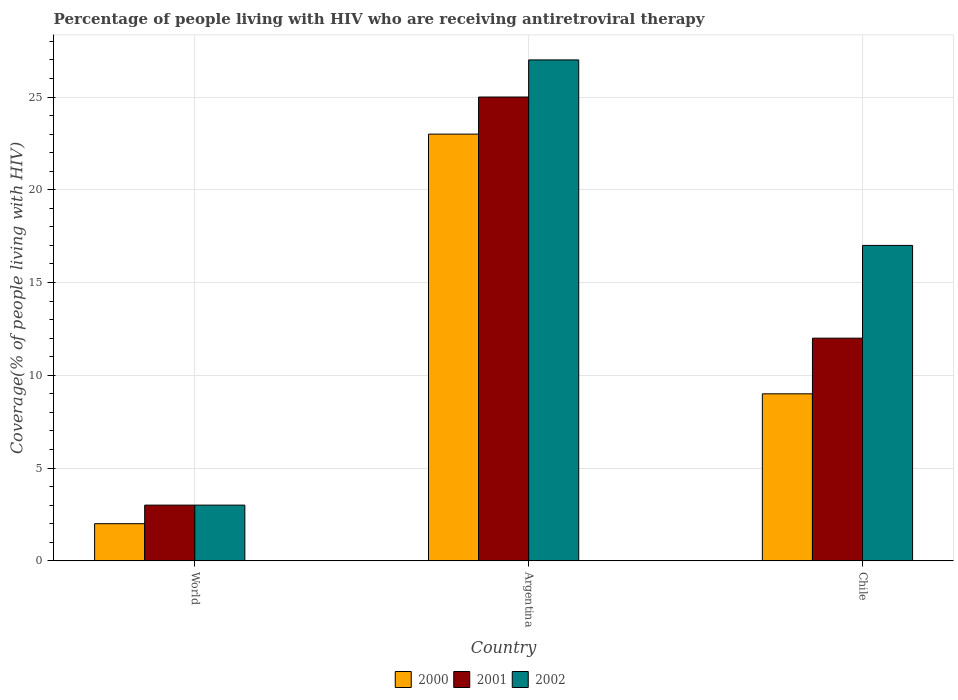How many different coloured bars are there?
Provide a short and direct response. 3. How many bars are there on the 2nd tick from the right?
Your answer should be very brief. 3. What is the label of the 2nd group of bars from the left?
Offer a terse response. Argentina. In how many cases, is the number of bars for a given country not equal to the number of legend labels?
Your answer should be compact. 0. What is the percentage of the HIV infected people who are receiving antiretroviral therapy in 2001 in Chile?
Give a very brief answer. 12. Across all countries, what is the minimum percentage of the HIV infected people who are receiving antiretroviral therapy in 2000?
Ensure brevity in your answer.  2. In which country was the percentage of the HIV infected people who are receiving antiretroviral therapy in 2000 minimum?
Your response must be concise. World. What is the total percentage of the HIV infected people who are receiving antiretroviral therapy in 2002 in the graph?
Ensure brevity in your answer.  47. What is the difference between the percentage of the HIV infected people who are receiving antiretroviral therapy in 2002 in Chile and that in World?
Provide a succinct answer. 14. What is the average percentage of the HIV infected people who are receiving antiretroviral therapy in 2000 per country?
Your answer should be very brief. 11.33. What is the difference between the percentage of the HIV infected people who are receiving antiretroviral therapy of/in 2000 and percentage of the HIV infected people who are receiving antiretroviral therapy of/in 2001 in World?
Your answer should be very brief. -1. What is the ratio of the percentage of the HIV infected people who are receiving antiretroviral therapy in 2000 in Argentina to that in World?
Your response must be concise. 11.5. Is the percentage of the HIV infected people who are receiving antiretroviral therapy in 2000 in Chile less than that in World?
Make the answer very short. No. What is the difference between the highest and the second highest percentage of the HIV infected people who are receiving antiretroviral therapy in 2002?
Your answer should be compact. -14. What is the difference between the highest and the lowest percentage of the HIV infected people who are receiving antiretroviral therapy in 2001?
Your answer should be very brief. 22. Is the sum of the percentage of the HIV infected people who are receiving antiretroviral therapy in 2002 in Chile and World greater than the maximum percentage of the HIV infected people who are receiving antiretroviral therapy in 2001 across all countries?
Offer a very short reply. No. What does the 2nd bar from the left in Argentina represents?
Your answer should be very brief. 2001. What does the 2nd bar from the right in Argentina represents?
Keep it short and to the point. 2001. Are all the bars in the graph horizontal?
Keep it short and to the point. No. How many countries are there in the graph?
Your answer should be very brief. 3. Does the graph contain any zero values?
Provide a short and direct response. No. Does the graph contain grids?
Your answer should be compact. Yes. Where does the legend appear in the graph?
Ensure brevity in your answer.  Bottom center. How are the legend labels stacked?
Provide a succinct answer. Horizontal. What is the title of the graph?
Keep it short and to the point. Percentage of people living with HIV who are receiving antiretroviral therapy. What is the label or title of the X-axis?
Give a very brief answer. Country. What is the label or title of the Y-axis?
Make the answer very short. Coverage(% of people living with HIV). What is the Coverage(% of people living with HIV) in 2002 in Argentina?
Offer a very short reply. 27. What is the Coverage(% of people living with HIV) in 2001 in Chile?
Your response must be concise. 12. Across all countries, what is the minimum Coverage(% of people living with HIV) in 2000?
Provide a short and direct response. 2. Across all countries, what is the minimum Coverage(% of people living with HIV) of 2001?
Offer a terse response. 3. Across all countries, what is the minimum Coverage(% of people living with HIV) of 2002?
Ensure brevity in your answer.  3. What is the total Coverage(% of people living with HIV) of 2000 in the graph?
Your answer should be compact. 34. What is the total Coverage(% of people living with HIV) of 2001 in the graph?
Offer a terse response. 40. What is the difference between the Coverage(% of people living with HIV) of 2000 in World and that in Argentina?
Provide a succinct answer. -21. What is the difference between the Coverage(% of people living with HIV) of 2001 in World and that in Chile?
Give a very brief answer. -9. What is the difference between the Coverage(% of people living with HIV) of 2000 in World and the Coverage(% of people living with HIV) of 2002 in Argentina?
Your answer should be very brief. -25. What is the difference between the Coverage(% of people living with HIV) in 2001 in World and the Coverage(% of people living with HIV) in 2002 in Argentina?
Give a very brief answer. -24. What is the difference between the Coverage(% of people living with HIV) in 2001 in World and the Coverage(% of people living with HIV) in 2002 in Chile?
Make the answer very short. -14. What is the difference between the Coverage(% of people living with HIV) in 2000 in Argentina and the Coverage(% of people living with HIV) in 2001 in Chile?
Offer a very short reply. 11. What is the average Coverage(% of people living with HIV) in 2000 per country?
Your answer should be compact. 11.33. What is the average Coverage(% of people living with HIV) in 2001 per country?
Keep it short and to the point. 13.33. What is the average Coverage(% of people living with HIV) in 2002 per country?
Keep it short and to the point. 15.67. What is the difference between the Coverage(% of people living with HIV) of 2000 and Coverage(% of people living with HIV) of 2001 in World?
Ensure brevity in your answer.  -1. What is the difference between the Coverage(% of people living with HIV) in 2000 and Coverage(% of people living with HIV) in 2001 in Argentina?
Provide a short and direct response. -2. What is the difference between the Coverage(% of people living with HIV) of 2000 and Coverage(% of people living with HIV) of 2002 in Argentina?
Offer a terse response. -4. What is the difference between the Coverage(% of people living with HIV) in 2001 and Coverage(% of people living with HIV) in 2002 in Argentina?
Offer a very short reply. -2. What is the difference between the Coverage(% of people living with HIV) of 2000 and Coverage(% of people living with HIV) of 2002 in Chile?
Keep it short and to the point. -8. What is the ratio of the Coverage(% of people living with HIV) of 2000 in World to that in Argentina?
Offer a very short reply. 0.09. What is the ratio of the Coverage(% of people living with HIV) in 2001 in World to that in Argentina?
Offer a terse response. 0.12. What is the ratio of the Coverage(% of people living with HIV) of 2000 in World to that in Chile?
Your response must be concise. 0.22. What is the ratio of the Coverage(% of people living with HIV) of 2001 in World to that in Chile?
Ensure brevity in your answer.  0.25. What is the ratio of the Coverage(% of people living with HIV) in 2002 in World to that in Chile?
Offer a terse response. 0.18. What is the ratio of the Coverage(% of people living with HIV) of 2000 in Argentina to that in Chile?
Ensure brevity in your answer.  2.56. What is the ratio of the Coverage(% of people living with HIV) in 2001 in Argentina to that in Chile?
Keep it short and to the point. 2.08. What is the ratio of the Coverage(% of people living with HIV) in 2002 in Argentina to that in Chile?
Keep it short and to the point. 1.59. What is the difference between the highest and the second highest Coverage(% of people living with HIV) of 2001?
Ensure brevity in your answer.  13. What is the difference between the highest and the second highest Coverage(% of people living with HIV) of 2002?
Your answer should be very brief. 10. What is the difference between the highest and the lowest Coverage(% of people living with HIV) in 2001?
Offer a terse response. 22. What is the difference between the highest and the lowest Coverage(% of people living with HIV) of 2002?
Your response must be concise. 24. 